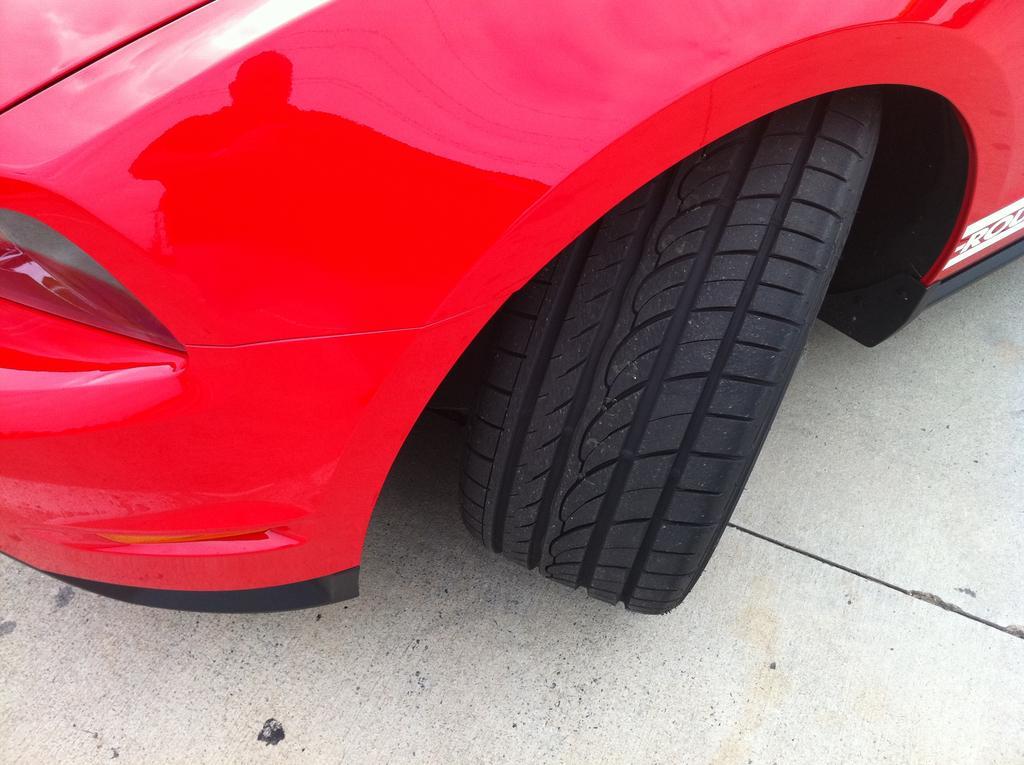Describe this image in one or two sentences. Picture of a red vehicle with black wheels on the surface. 